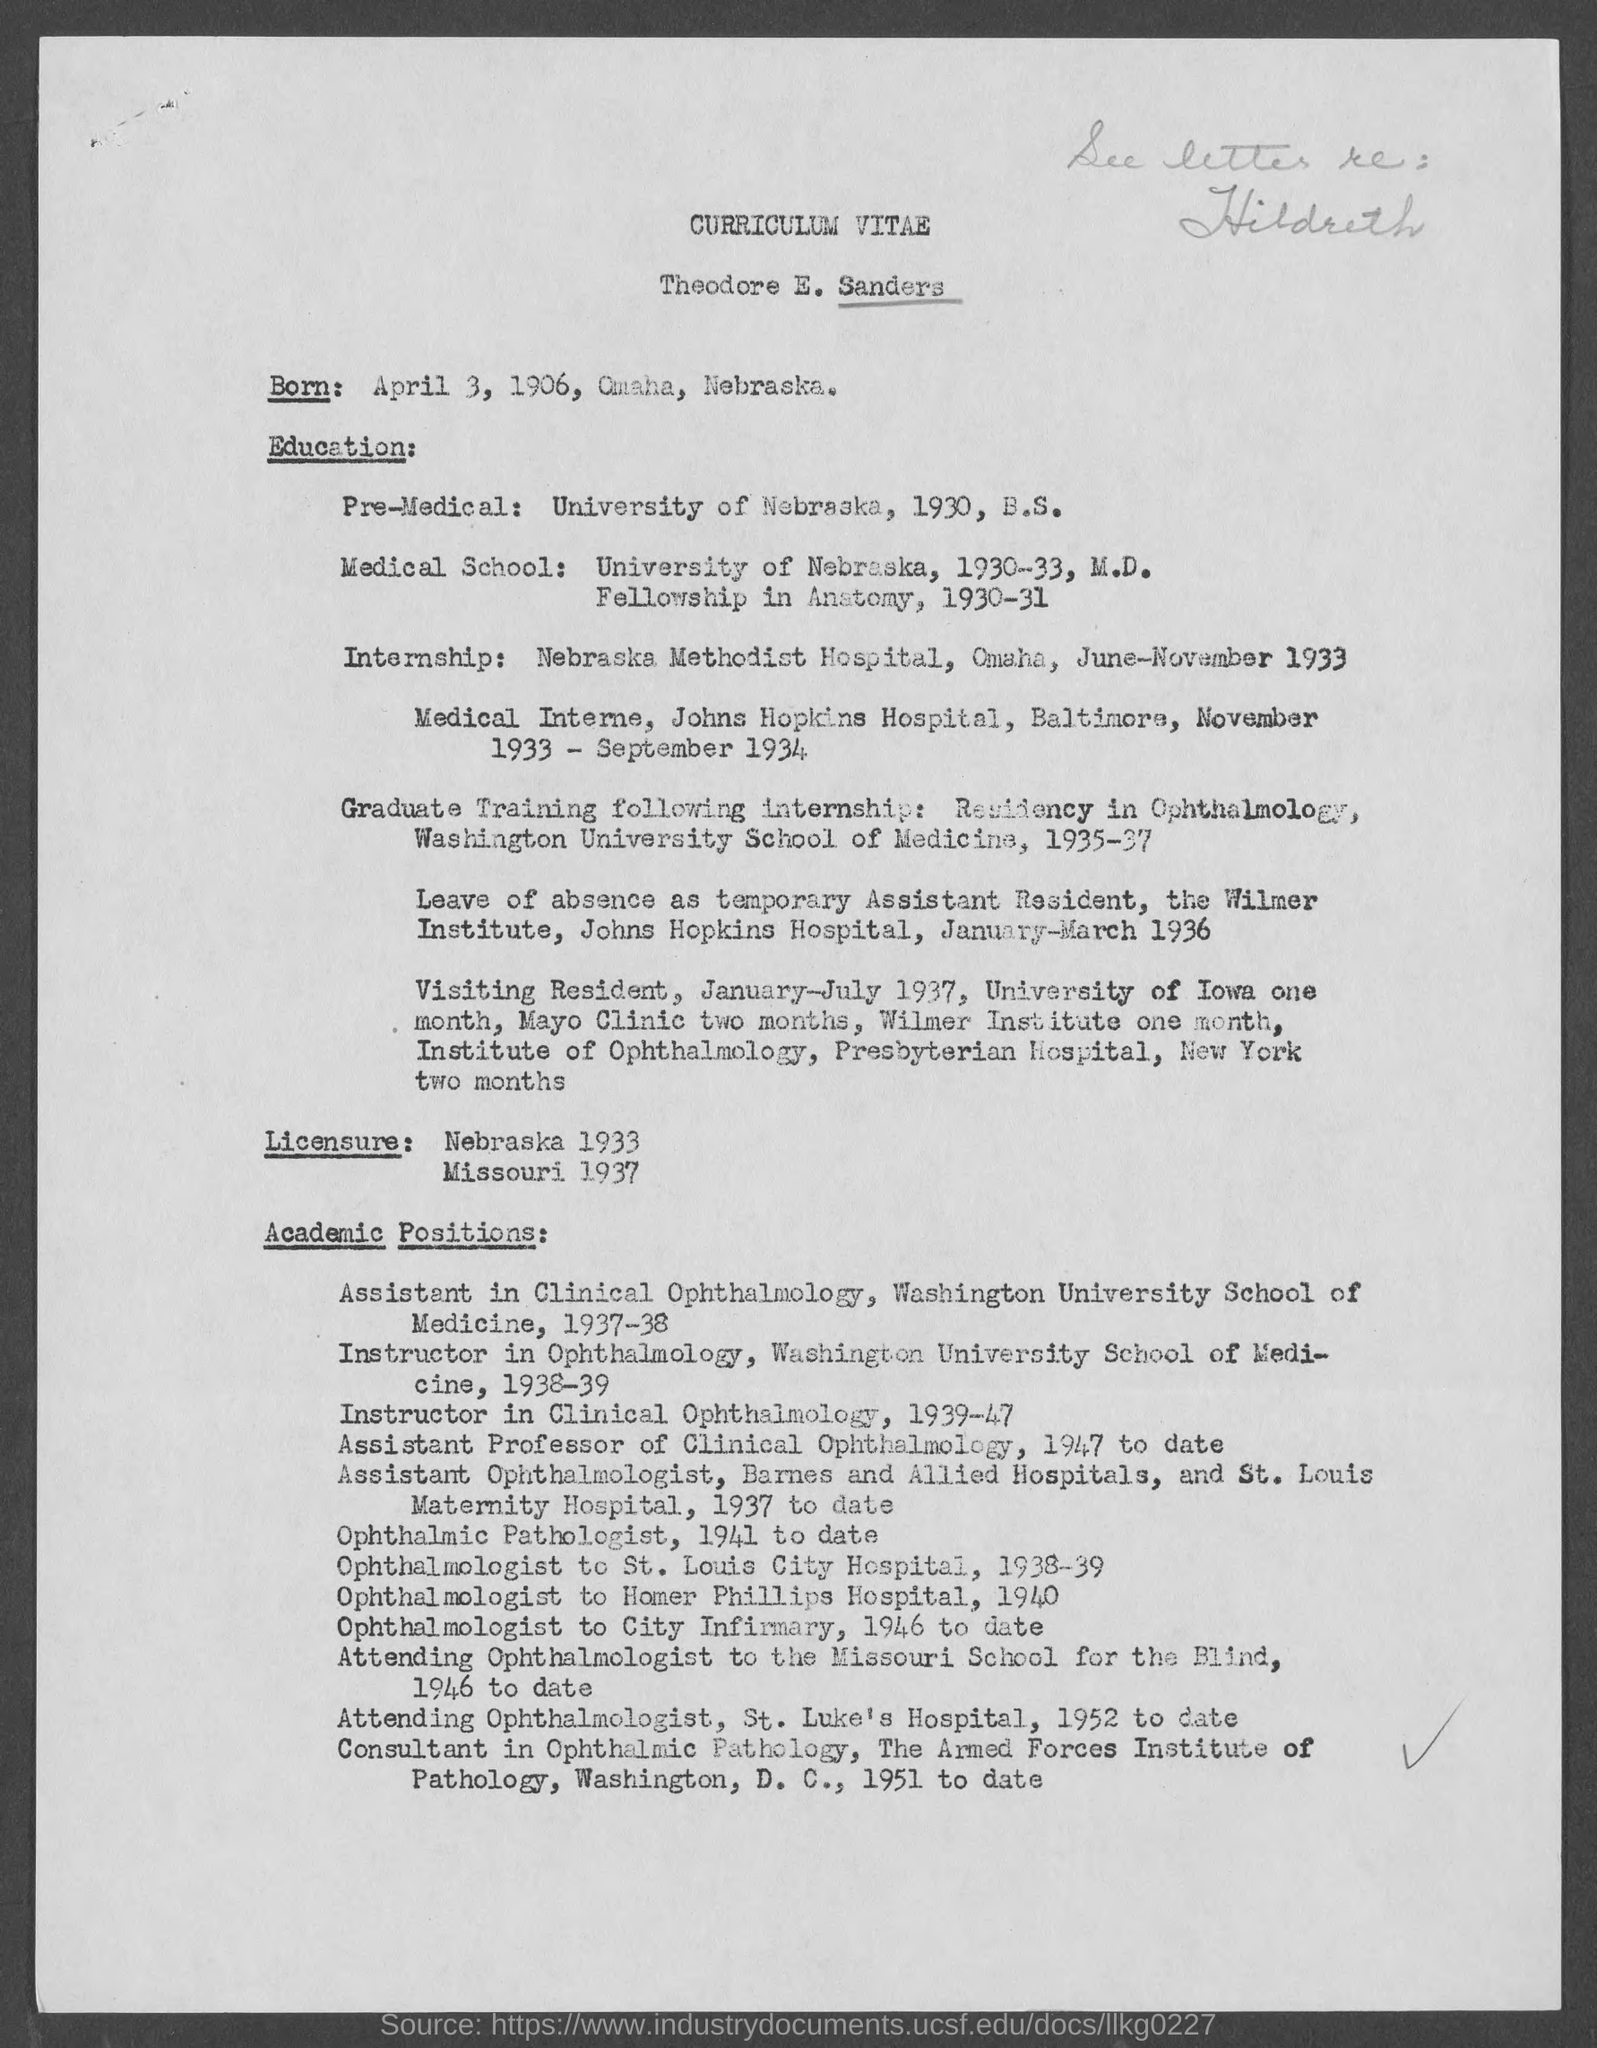Point out several critical features in this image. The name listed on the curriculum vitae is "Theodore E. Sanders. Theodore E. Sanders served as an instructor in clinical ophthalmology from 1939 to 1947. 